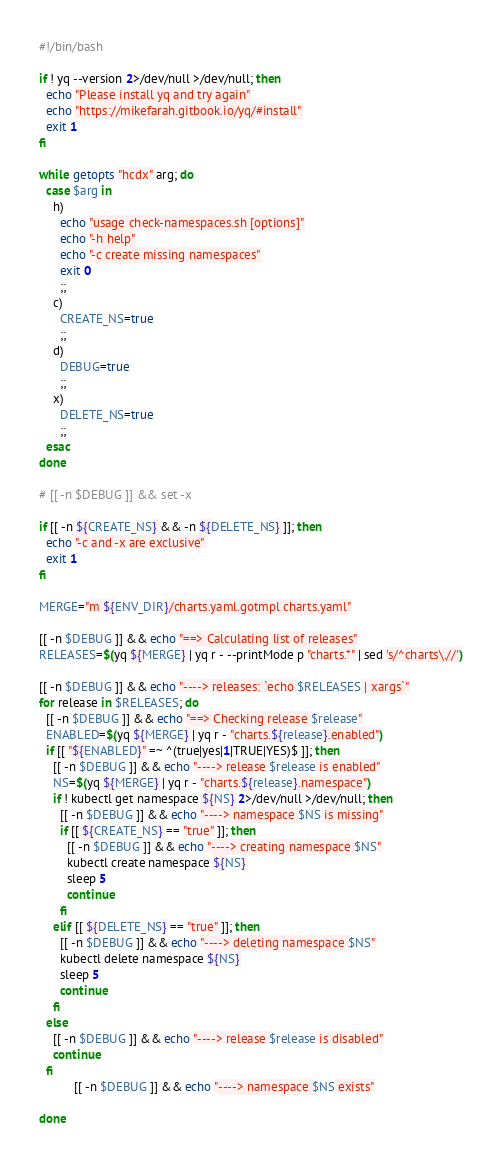<code> <loc_0><loc_0><loc_500><loc_500><_Bash_>#!/bin/bash

if ! yq --version 2>/dev/null >/dev/null; then
  echo "Please install yq and try again"
  echo "https://mikefarah.gitbook.io/yq/#install"
  exit 1
fi

while getopts "hcdx" arg; do
  case $arg in
    h)
      echo "usage check-namespaces.sh [options]"
      echo "-h help"
      echo "-c create missing namespaces"
      exit 0
      ;;
    c)
      CREATE_NS=true
      ;;
    d)
      DEBUG=true
      ;;
    x)
      DELETE_NS=true
      ;;
  esac
done

# [[ -n $DEBUG ]] && set -x

if [[ -n ${CREATE_NS} && -n ${DELETE_NS} ]]; then
  echo "-c and -x are exclusive"
  exit 1
fi

MERGE="m ${ENV_DIR}/charts.yaml.gotmpl charts.yaml"

[[ -n $DEBUG ]] && echo "==> Calculating list of releases"
RELEASES=$(yq ${MERGE} | yq r - --printMode p "charts.*" | sed 's/^charts\.//')

[[ -n $DEBUG ]] && echo "----> releases: `echo $RELEASES | xargs`"
for release in $RELEASES; do
  [[ -n $DEBUG ]] && echo "==> Checking release $release"
  ENABLED=$(yq ${MERGE} | yq r - "charts.${release}.enabled")
  if [[ "${ENABLED}" =~ ^(true|yes|1|TRUE|YES)$ ]]; then
    [[ -n $DEBUG ]] && echo "----> release $release is enabled"
    NS=$(yq ${MERGE} | yq r - "charts.${release}.namespace")
    if ! kubectl get namespace ${NS} 2>/dev/null >/dev/null; then
      [[ -n $DEBUG ]] && echo "----> namespace $NS is missing"
      if [[ ${CREATE_NS} == "true" ]]; then
        [[ -n $DEBUG ]] && echo "----> creating namespace $NS"
        kubectl create namespace ${NS}
        sleep 5
        continue
      fi
    elif [[ ${DELETE_NS} == "true" ]]; then
      [[ -n $DEBUG ]] && echo "----> deleting namespace $NS"
      kubectl delete namespace ${NS}
      sleep 5
      continue
    fi
  else
    [[ -n $DEBUG ]] && echo "----> release $release is disabled"
    continue
  fi
          [[ -n $DEBUG ]] && echo "----> namespace $NS exists"

done</code> 